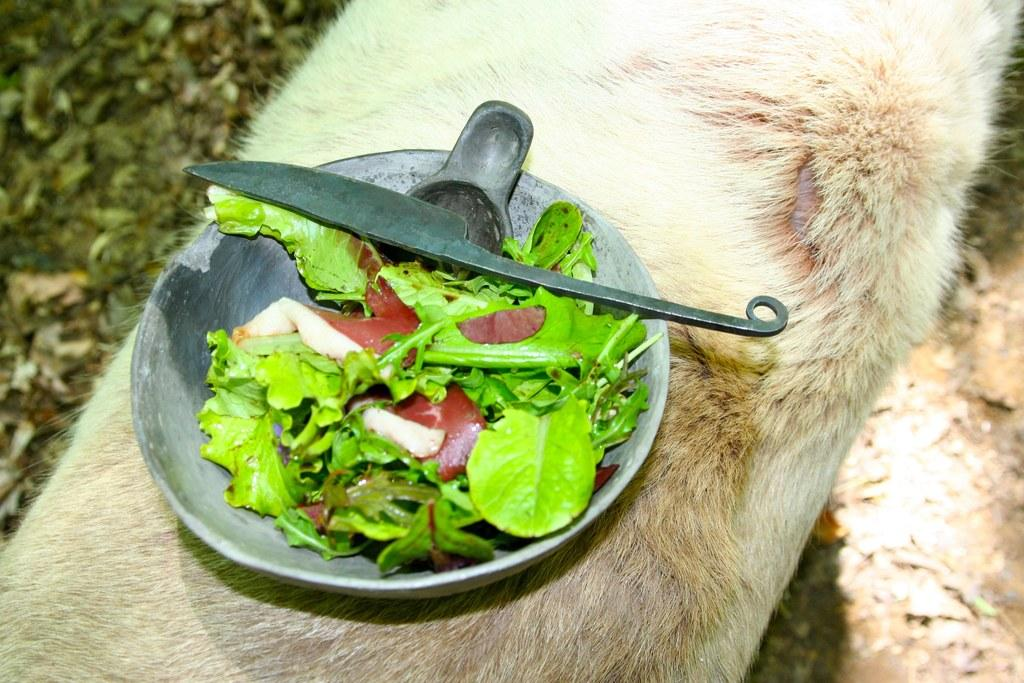What is in the bowl that is visible in the image? There are leaves in a bowl. What utensil is placed with the bowl? There is a knife on the bowl. On what is the bowl placed? The bowl is placed on an animal. How many kittens are present in the image? There are no kittens present in the image. The bowl is placed on an animal, but the type of animal is not specified, and there is no mention of kittens. 